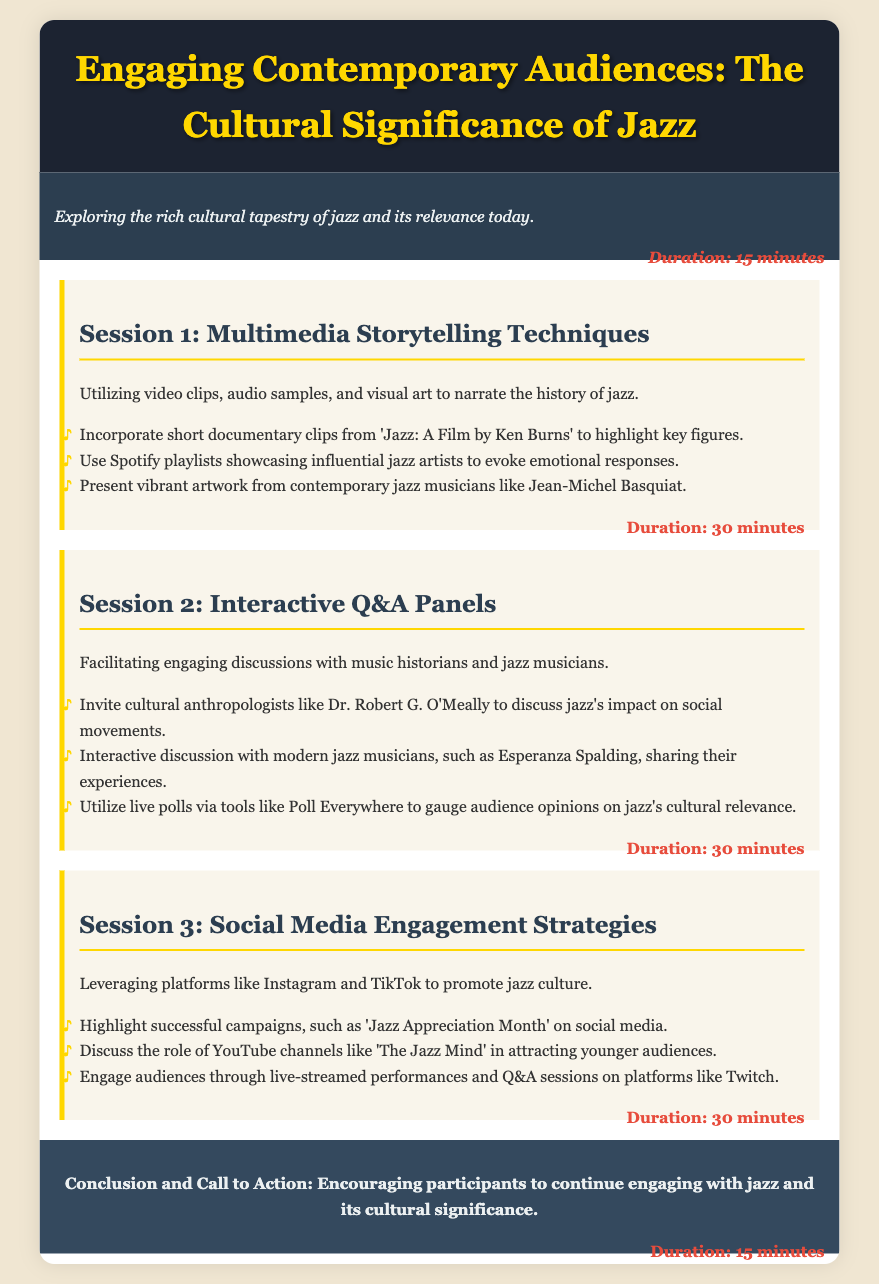What is the title of the document? The title is clearly stated at the top of the document, indicating the main topic of the agenda.
Answer: Engaging Contemporary Audiences: The Cultural Significance of Jazz What is the duration of the introduction? The duration for the introduction section is specified right after the introductory paragraph.
Answer: 15 minutes Who is featured in Session 2 for discussion on jazz's impact on social movements? The document mentions a specific cultural anthropologist invited for the discussion.
Answer: Dr. Robert G. O'Meally What platforms are discussed in Session 3 for promoting jazz culture? The session's content specifies the social media platforms that are leveraged.
Answer: Instagram and TikTok How long is each session in the document? Each session has a duration listed, contributing to the overall schedule of the agenda.
Answer: 30 minutes What is the total duration of the sessions mentioned in the document? The document states the duration of each component, which can be summed up for total time.
Answer: 105 minutes What type of multimedia techniques are mentioned in Session 1? The session outlines specific types of media used to enhance storytelling about jazz.
Answer: Video clips, audio samples, and visual art What is the main call to action at the end of the document? The concluding section explicitly outlines what participants are encouraged to do after the agenda.
Answer: Continue engaging with jazz and its cultural significance What type of event format is suggested in Session 2? The document describes a specific interactive format for engaging discussions.
Answer: Interactive Q&A Panels 